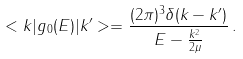<formula> <loc_0><loc_0><loc_500><loc_500>< { k } | g _ { 0 } ( E ) | { k } ^ { \prime } > = \frac { ( 2 \pi ) ^ { 3 } \delta ( { k } - { k } ^ { \prime } ) } { E - \frac { k ^ { 2 } } { 2 \mu } } \, .</formula> 